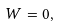<formula> <loc_0><loc_0><loc_500><loc_500>W = 0 ,</formula> 